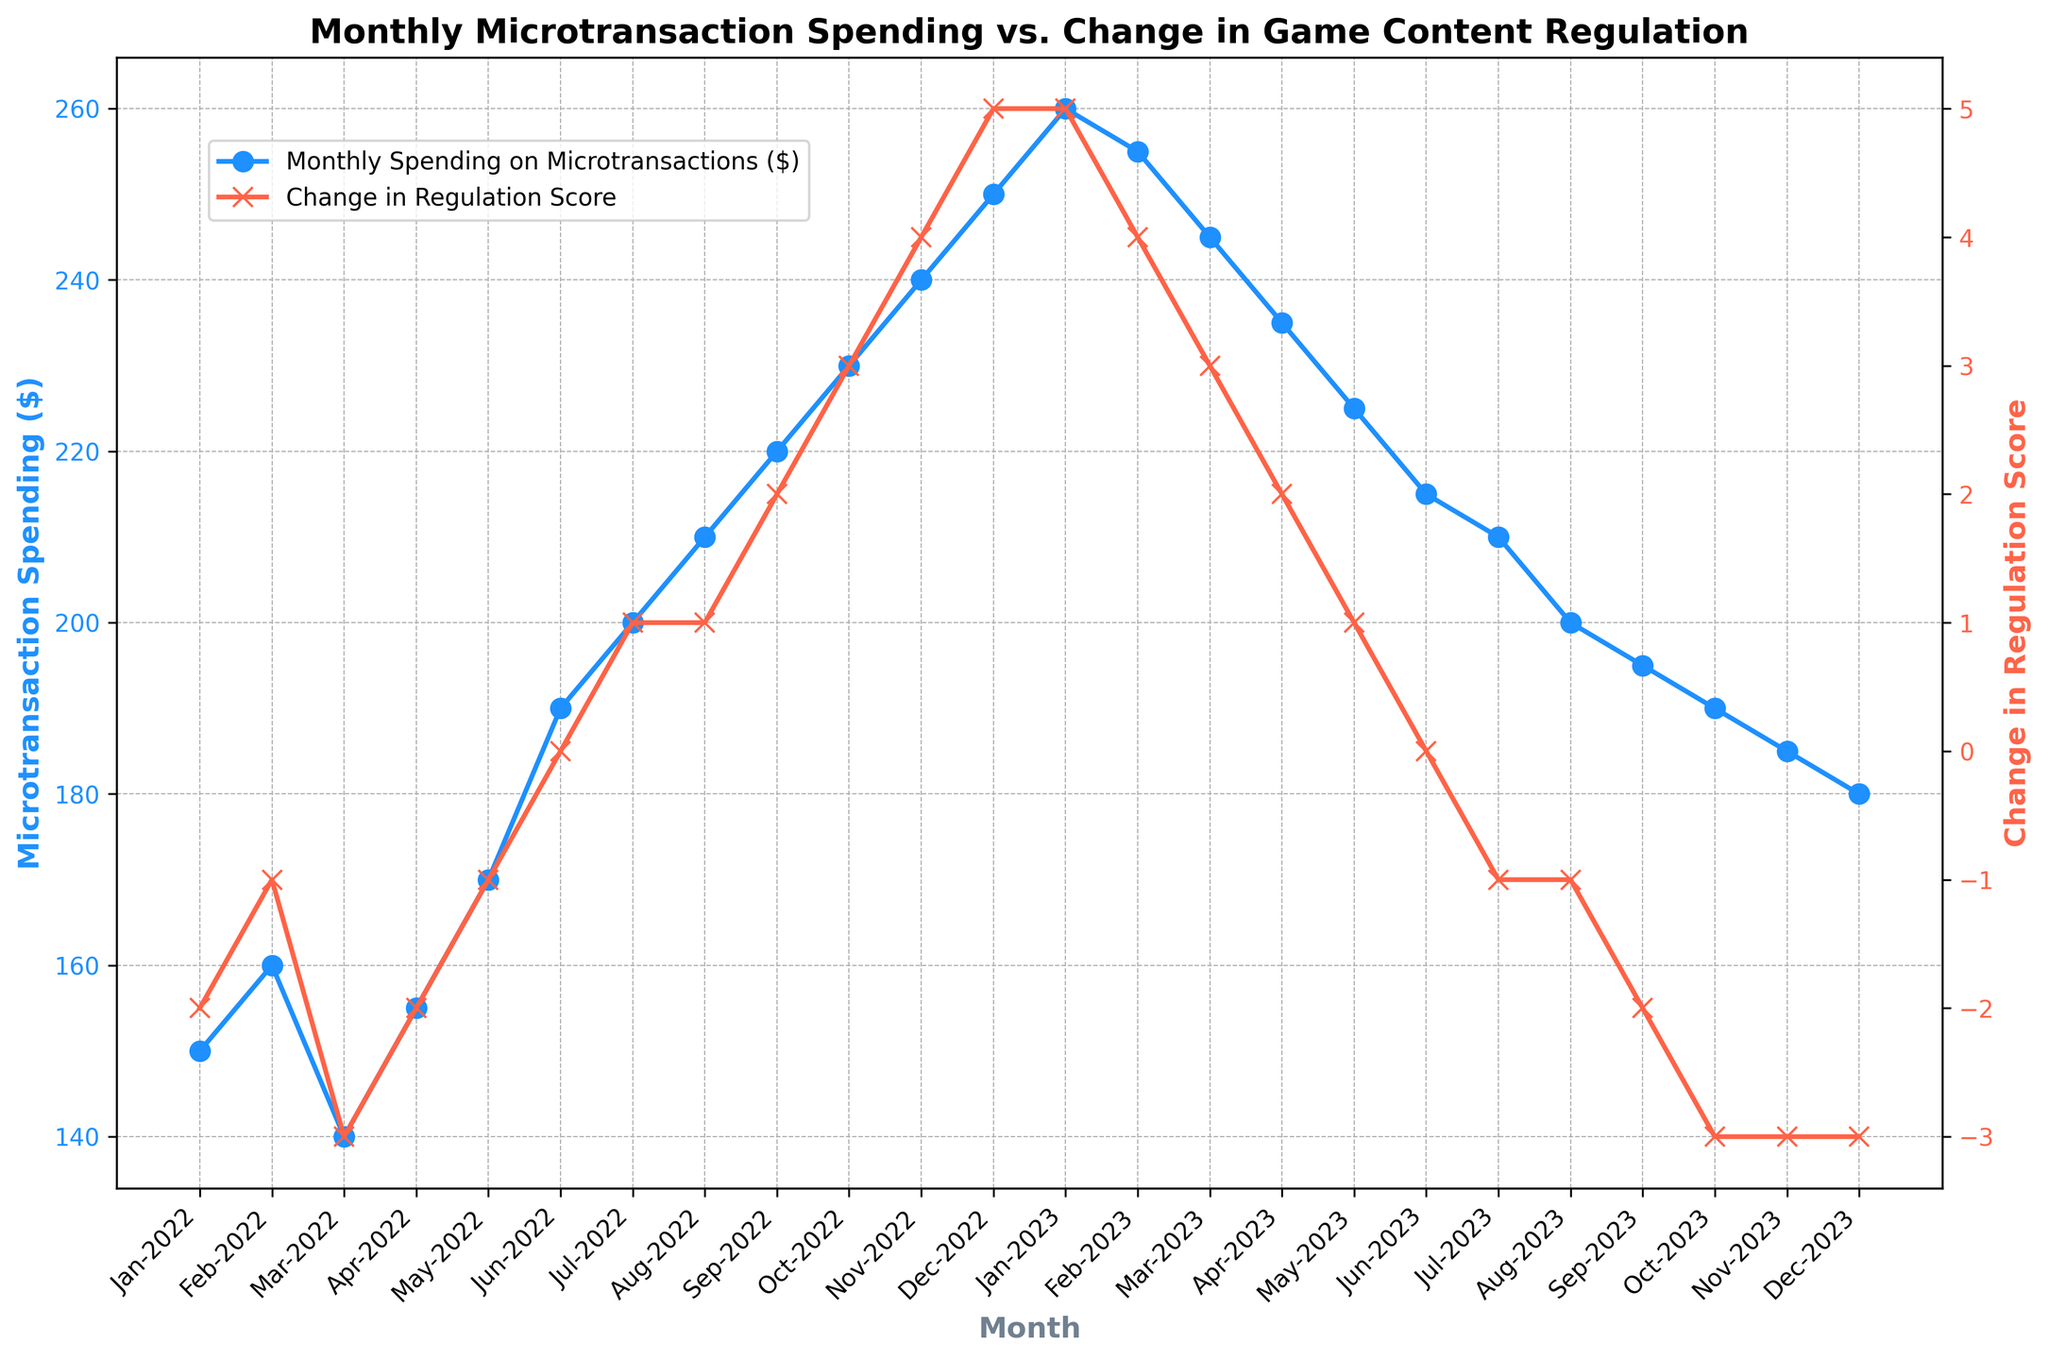What was the monthly spending on microtransactions in October 2022? In October 2022, use the blue line corresponding to microtransaction spending to find the y-value. The plot shows the spending as $230.
Answer: $230 Which month saw the highest spending on microtransactions in 2023, and what was the amount? Look for the highest point on the blue line in 2023. The peak is in January 2023 with a spending of $260.
Answer: January 2023, $260 How did the regulation score change between June 2022 and June 2023? The regulation score in June 2022 is 0 and in June 2023, it is 0. The difference is 0 - 0 = 0.
Answer: 0 What is the correlation between the trend in microtransaction spending and regulation changes from January 2022 to December 2022? By observing the trends, from Jan-2022 to Dec-2022, microtransaction spending increases as regulation becomes less restrictive (score rises from -2 to 5). Therefore, there's a positive correlation where more spending aligns with less restrictive regulations.
Answer: Positive correlation Between which consecutive months was the largest decrease in monthly spending on microtransactions observed, and how much did it drop? Inspect the blue line for the largest downward slope. The largest drop is between January 2023 ($260) and February 2023 ($255). The difference is $260 - $255 = $5.
Answer: January 2023 to February 2023, $5 What is the total change in the regulation score from January 2022 to December 2023? The regulation score in January 2022 is -2 and in December 2023, it is -3. The total change is -3 - (-2) = -1.
Answer: -1 Identify the month when the regulation score started becoming positive in 2022 and the corresponding microtransaction spending. The red line indicating regulation score becomes positive in July 2022 (+1) with the corresponding microtransaction spending of $200.
Answer: July 2022, $200 Compare the microtransaction spending and regulation score in December 2022 and December 2023. Which one had a higher microtransaction spending and by how much? December 2022 spending is $250, and December 2023 spending is $180. The difference is $250 - $180 = $70. Regulation score also drops from 5 in December 2022 to -3 in December 2023.
Answer: December 2022 had higher spending by $70 Which month saw the sharpest increase in the regulation score and what was the change? Look for the steepest rise in the red line. The highest increase is from September 2022 (+2) to October 2022 (+3), a change of 3 - 2 = 1.
Answer: October 2022, increase by 1 In which year, 2022 or 2023, was the average monthly spending on microtransactions higher? Calculate the average spending for each year: 2022 total spending = $2400, average = $2400/12 = $200; 2023 total spending = $2760, average = $2760/12 = $230.
Answer: 2023 